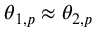Convert formula to latex. <formula><loc_0><loc_0><loc_500><loc_500>\theta _ { 1 , p } \approx \theta _ { 2 , p }</formula> 